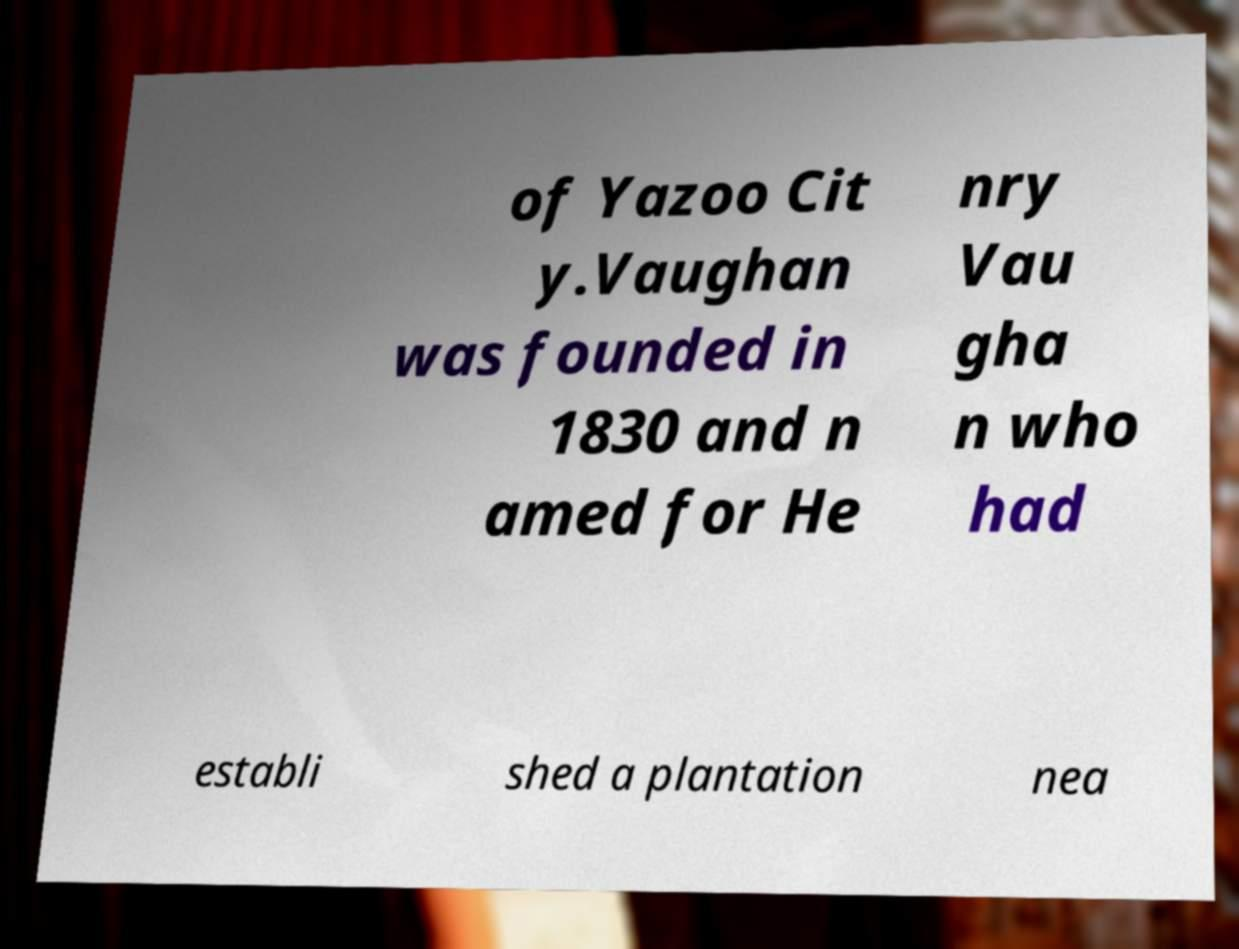Can you accurately transcribe the text from the provided image for me? of Yazoo Cit y.Vaughan was founded in 1830 and n amed for He nry Vau gha n who had establi shed a plantation nea 